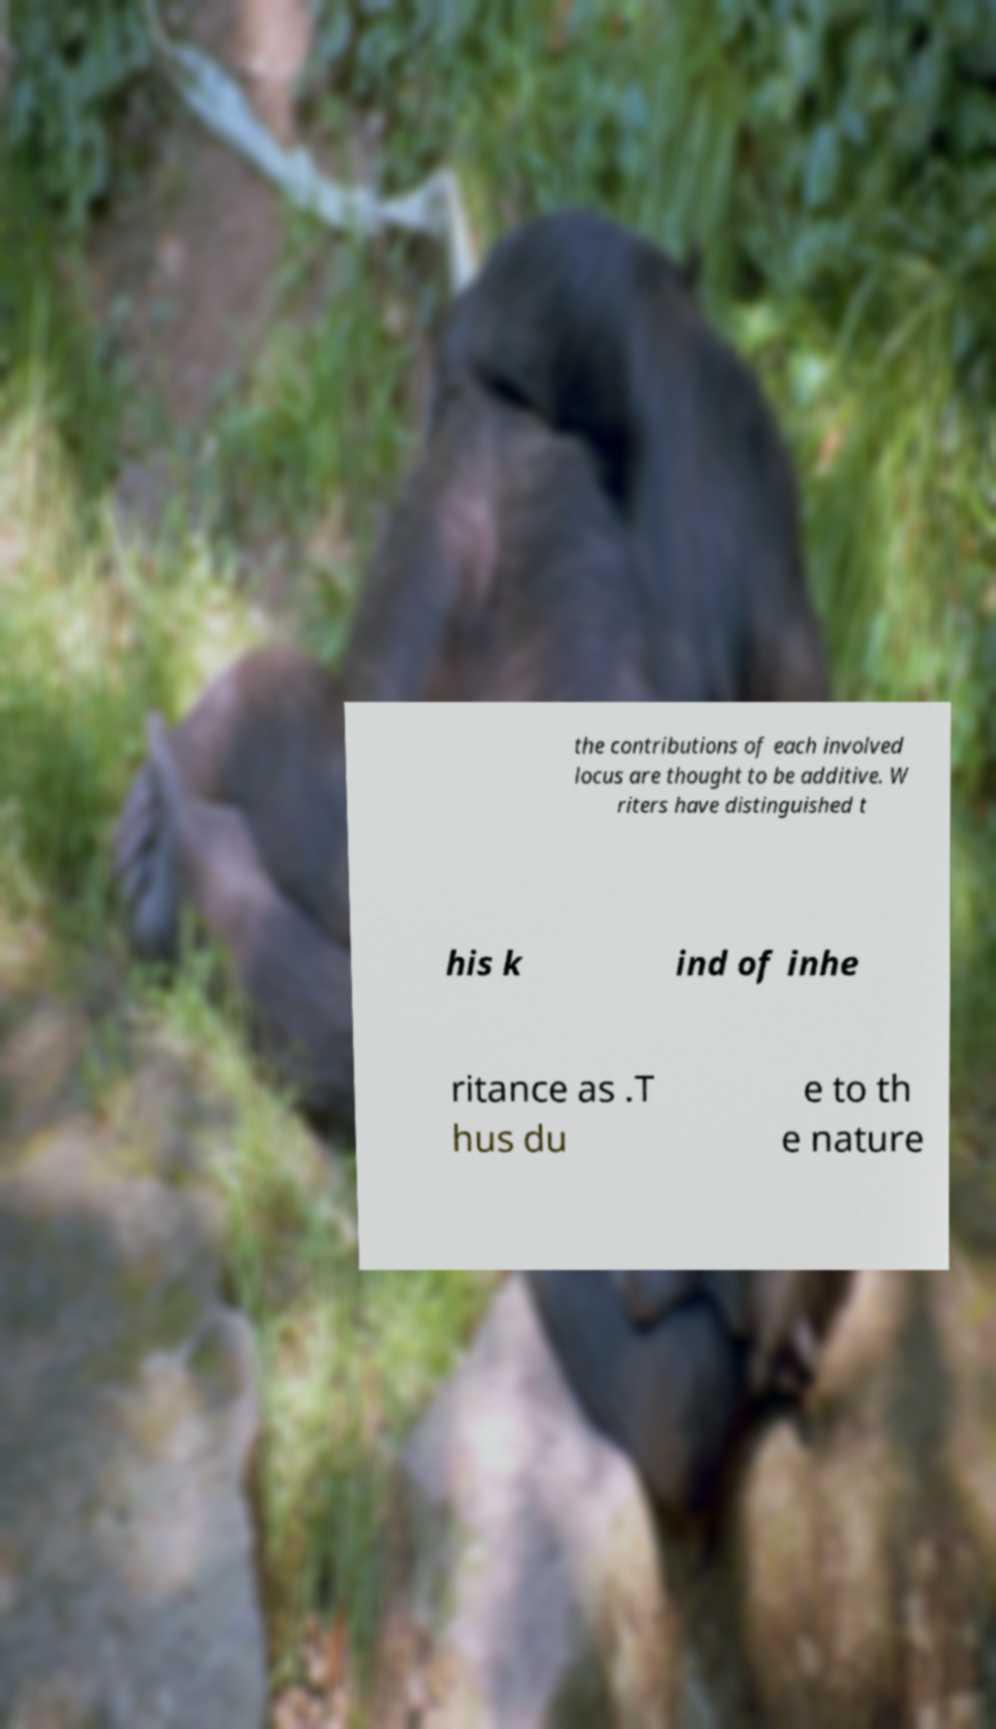Can you read and provide the text displayed in the image?This photo seems to have some interesting text. Can you extract and type it out for me? the contributions of each involved locus are thought to be additive. W riters have distinguished t his k ind of inhe ritance as .T hus du e to th e nature 